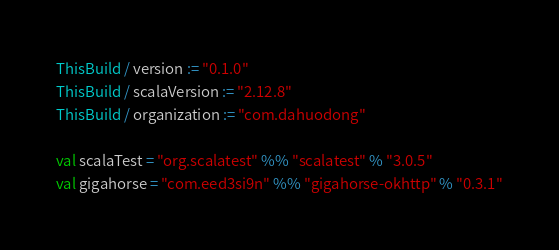Convert code to text. <code><loc_0><loc_0><loc_500><loc_500><_Scala_>ThisBuild / version := "0.1.0"
ThisBuild / scalaVersion := "2.12.8"
ThisBuild / organization := "com.dahuodong"

val scalaTest = "org.scalatest" %% "scalatest" % "3.0.5"
val gigahorse = "com.eed3si9n" %% "gigahorse-okhttp" % "0.3.1"</code> 